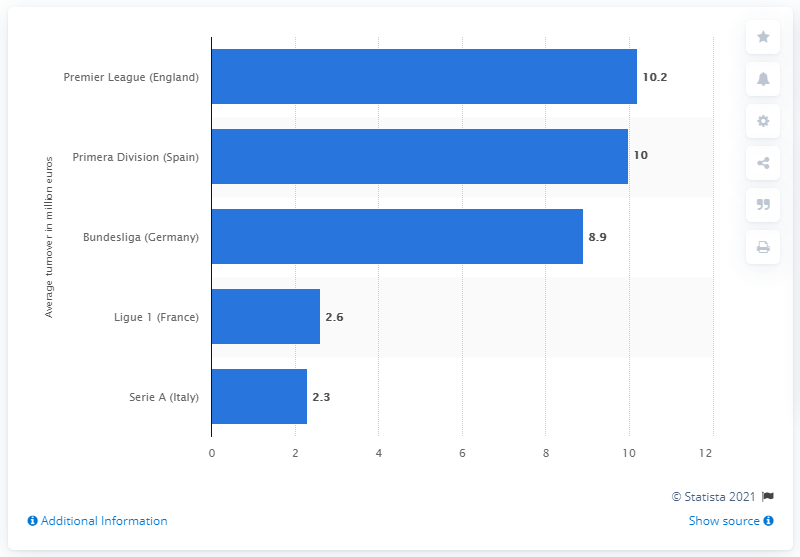Indicate a few pertinent items in this graphic. The average turnover from merchandising in the German Bundesliga during the 2012/13 season was 8.9. 